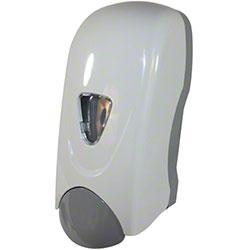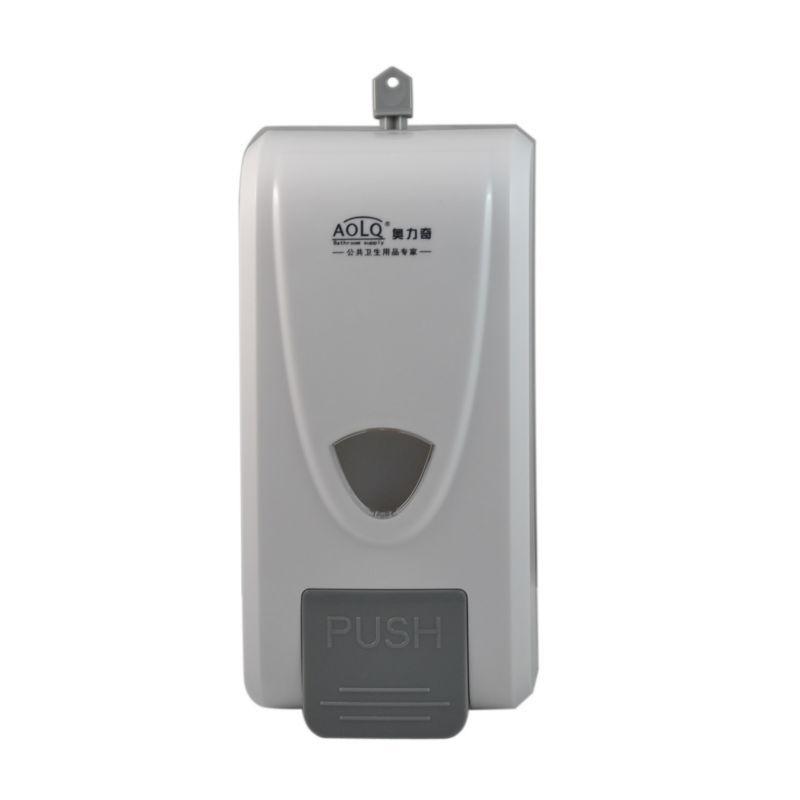The first image is the image on the left, the second image is the image on the right. Considering the images on both sides, is "There is a grey button on the machine on the left." valid? Answer yes or no. Yes. The first image is the image on the left, the second image is the image on the right. Given the left and right images, does the statement "One or more of the dispensers has a chrome finish." hold true? Answer yes or no. No. 